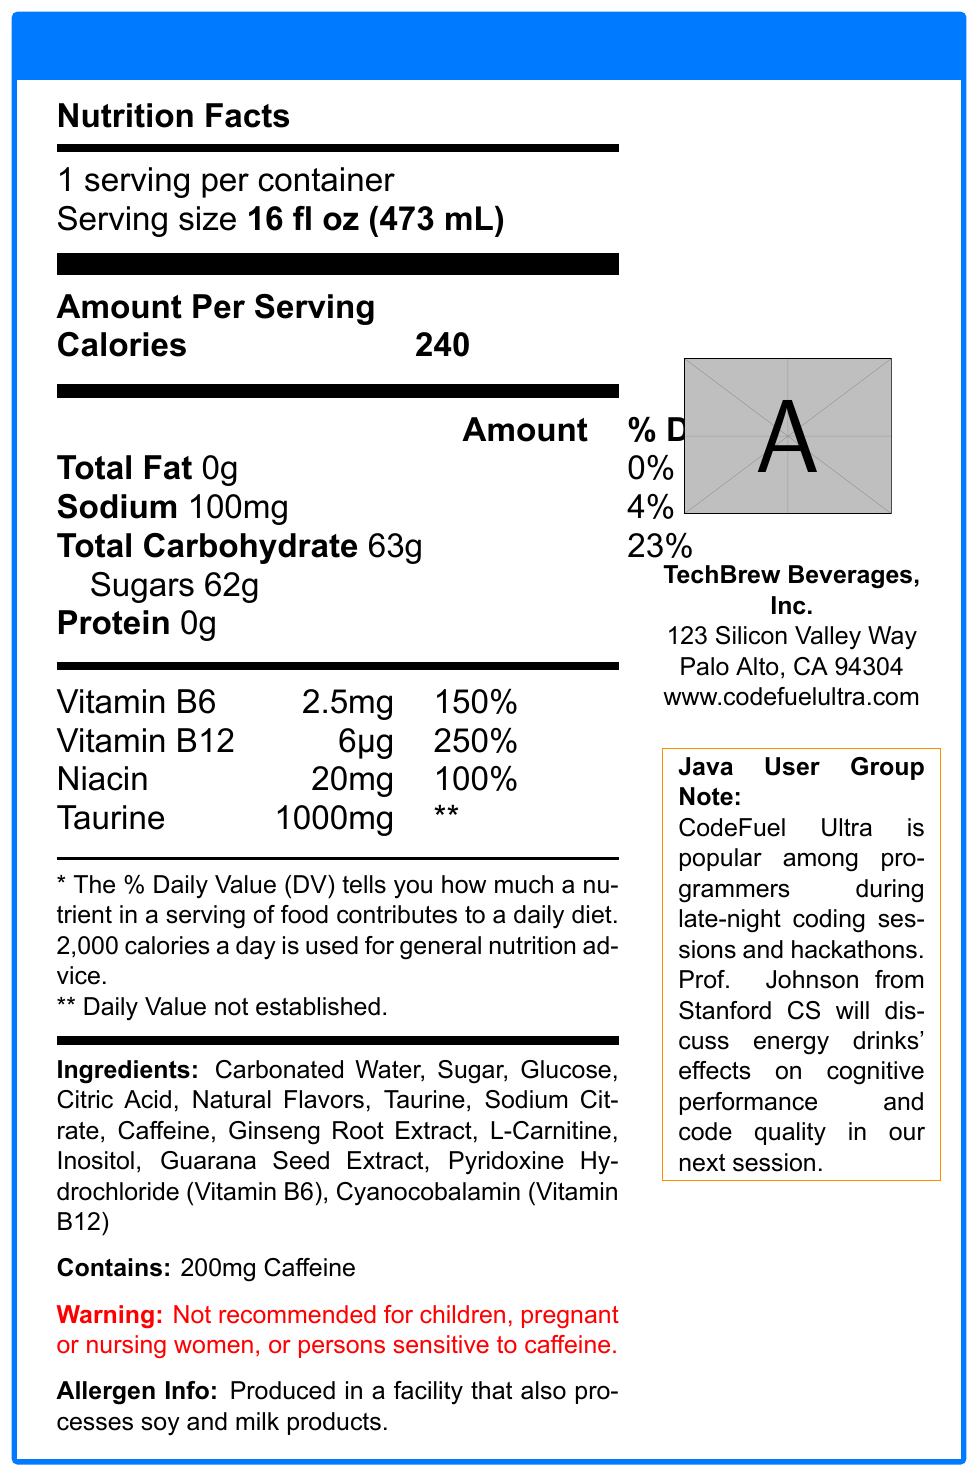how many calories are in a serving of CodeFuel Ultra? The document lists the calories per serving as 240 in the nutrition facts section.
Answer: 240 what is the serving size of CodeFuel Ultra? The serving size is specified at the beginning of the nutrition facts section as "16 fl oz (473 mL)".
Answer: 16 fl oz (473 mL) how much caffeine does CodeFuel Ultra contain? The amount of caffeine is mentioned in both the nutrition facts and the ingredient list.
Answer: 200mg which vitamins and minerals are listed in CodeFuel Ultra? These vitamins and minerals are detailed in the vitamins and minerals section of the document.
Answer: Vitamin B6, Vitamin B12, Niacin, Taurine what is the percentage daily value of Vitamin B12 in CodeFuel Ultra? The document lists the percentage daily value of Vitamin B12 as 250% in the nutrition facts section.
Answer: 250% CodeFuel Ultra is produced in a facility that also processes which allergens? The allergen info section states that the product is produced in a facility that also processes soy and milk products.
Answer: soy and milk products how many grams of total carbohydrates are in a serving of CodeFuel Ultra? The nutrition facts section lists total carbohydrates as 63g per serving.
Answer: 63g are there any warnings associated with consuming CodeFuel Ultra? The warning section indicates that the product is not recommended for children, pregnant or nursing women, or persons sensitive to caffeine.
Answer: Yes who is the manufacturer of CodeFuel Ultra? The manufacturer information provided lists TechBrew Beverages, Inc. as the manufacturer.
Answer: TechBrew Beverages, Inc. what is the address of the manufacturer? The document includes this address under the manufacturer details.
Answer: 123 Silicon Valley Way, Palo Alto, CA 94304 which ingredient is listed first in the ingredients list? The first ingredient listed is Carbonated Water.
Answer: Carbonated Water what is the main idea of the Nutrition Facts Label for CodeFuel Ultra? The detailed description includes the serving size, calories, ingredients, and allergen information, with a note on usage among programmers.
Answer: CodeFuel Ultra Nutrition Facts Label provides detailed information on the nutritional content, ingredients, allergens, and manufacturer of the product. It highlights the high caffeine content and specific vitamins and their daily values, alongside explicit warnings. does CodeFuel Ultra contain any protein? The nutrition facts section lists protein as 0g.
Answer: No how many servings per container are there for CodeFuel Ultra? The document specifies that there is 1 serving per container.
Answer: 1 what percentage of the daily value for sodium does CodeFuel Ultra provide? The nutrition facts section lists sodium as 100mg, which is 4% of the daily value.
Answer: 4% which of these ingredients is NOT listed in CodeFuel Ultra? A. Guarana Seed Extract B. Aspartame C. Citric Acid D. L-Carnitine The ingredient list includes Guarana Seed Extract, Citric Acid, and L-Carnitine but does not mention Aspartame.
Answer: B. Aspartame how much Taurine is in CodeFuel Ultra? A. 100mg B. 250mg C. 500mg D. 1000mg The document lists Taurine as 1000mg in the vitamins and minerals section.
Answer: D. 1000mg is CodeFuel Ultra recommended for children? The warning section explicitly states that it is not recommended for children.
Answer: No who will discuss the effects of energy drinks at the next meetup? The meetup note states that Professor Johnson will discuss the effects of energy drinks.
Answer: Professor Johnson from Stanford's Computer Science department what is the percentage daily value of total fat in CodeFuel Ultra? The nutrition facts list total fat as 0g with a daily value percentage of 0%.
Answer: 0% how often should CodeFuel Ultra be consumed to stay within the recommended daily caffeine intake? The document does not provide enough information regarding the recommended daily intake of caffeine or how often it should be consumed.
Answer: Cannot be determined 